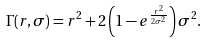Convert formula to latex. <formula><loc_0><loc_0><loc_500><loc_500>\Gamma ( r , \sigma ) = r ^ { 2 } + 2 \left ( 1 - e ^ { \frac { r ^ { 2 } } { 2 \sigma ^ { 2 } } } \right ) \sigma ^ { 2 } .</formula> 